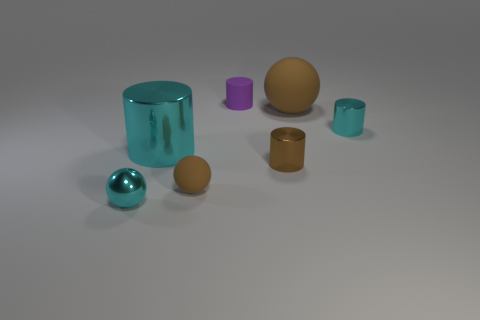Subtract all small brown cylinders. How many cylinders are left? 3 Subtract 1 spheres. How many spheres are left? 2 Subtract all brown cylinders. How many cylinders are left? 3 Add 1 green shiny balls. How many objects exist? 8 Subtract all green spheres. Subtract all red cylinders. How many spheres are left? 3 Subtract all balls. How many objects are left? 4 Add 5 brown metal things. How many brown metal things are left? 6 Add 1 tiny cyan objects. How many tiny cyan objects exist? 3 Subtract 1 brown cylinders. How many objects are left? 6 Subtract all cyan cylinders. Subtract all cyan balls. How many objects are left? 4 